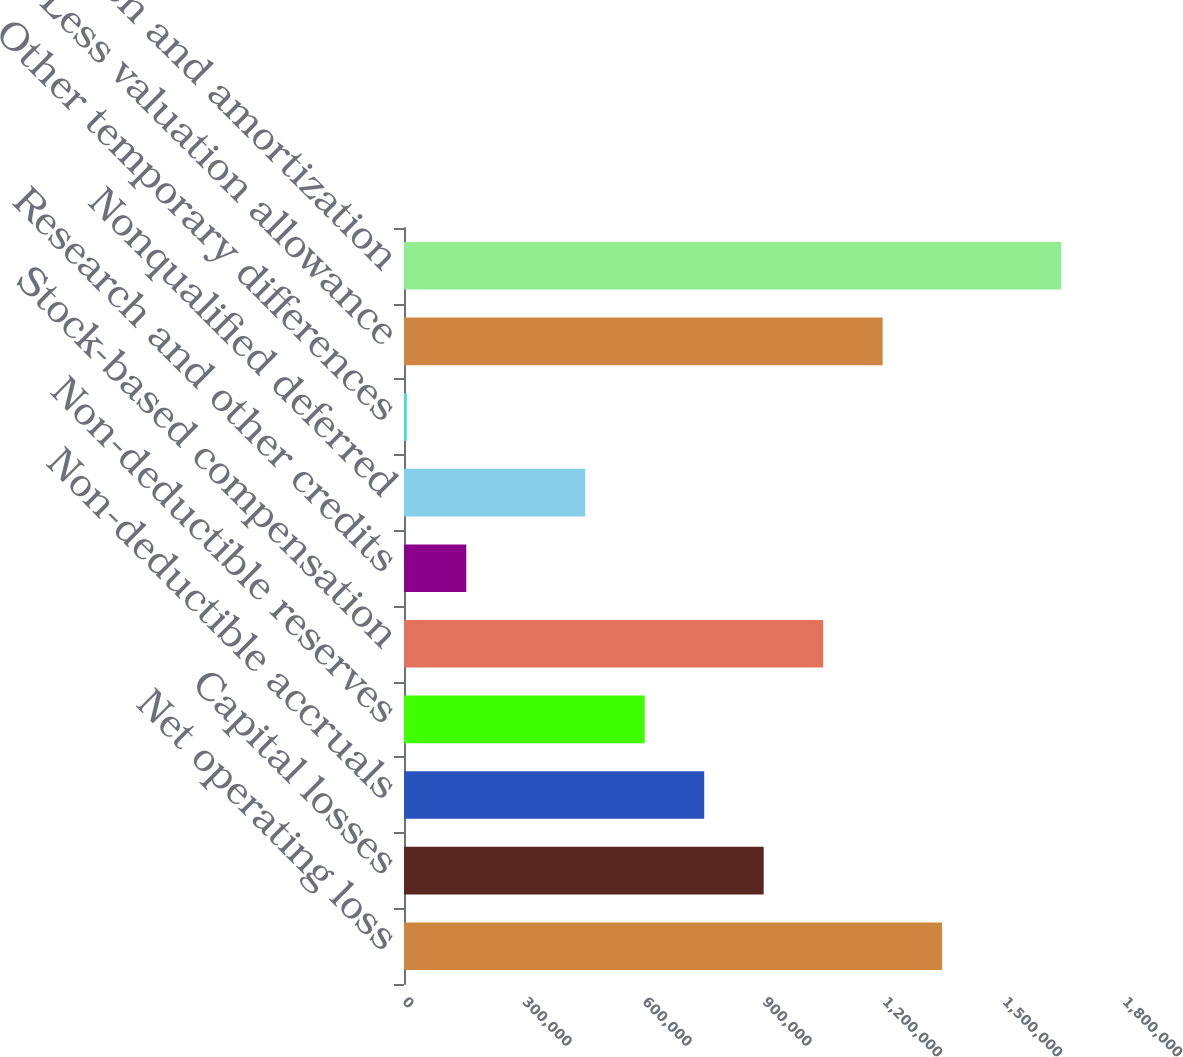Convert chart to OTSL. <chart><loc_0><loc_0><loc_500><loc_500><bar_chart><fcel>Net operating loss<fcel>Capital losses<fcel>Non-deductible accruals<fcel>Non-deductible reserves<fcel>Stock-based compensation<fcel>Research and other credits<fcel>Nonqualified deferred<fcel>Other temporary differences<fcel>Less valuation allowance<fcel>Depreciation and amortization<nl><fcel>1.34536e+06<fcel>899225<fcel>750514<fcel>601803<fcel>1.04794e+06<fcel>155671<fcel>453092<fcel>6960<fcel>1.19665e+06<fcel>1.64278e+06<nl></chart> 